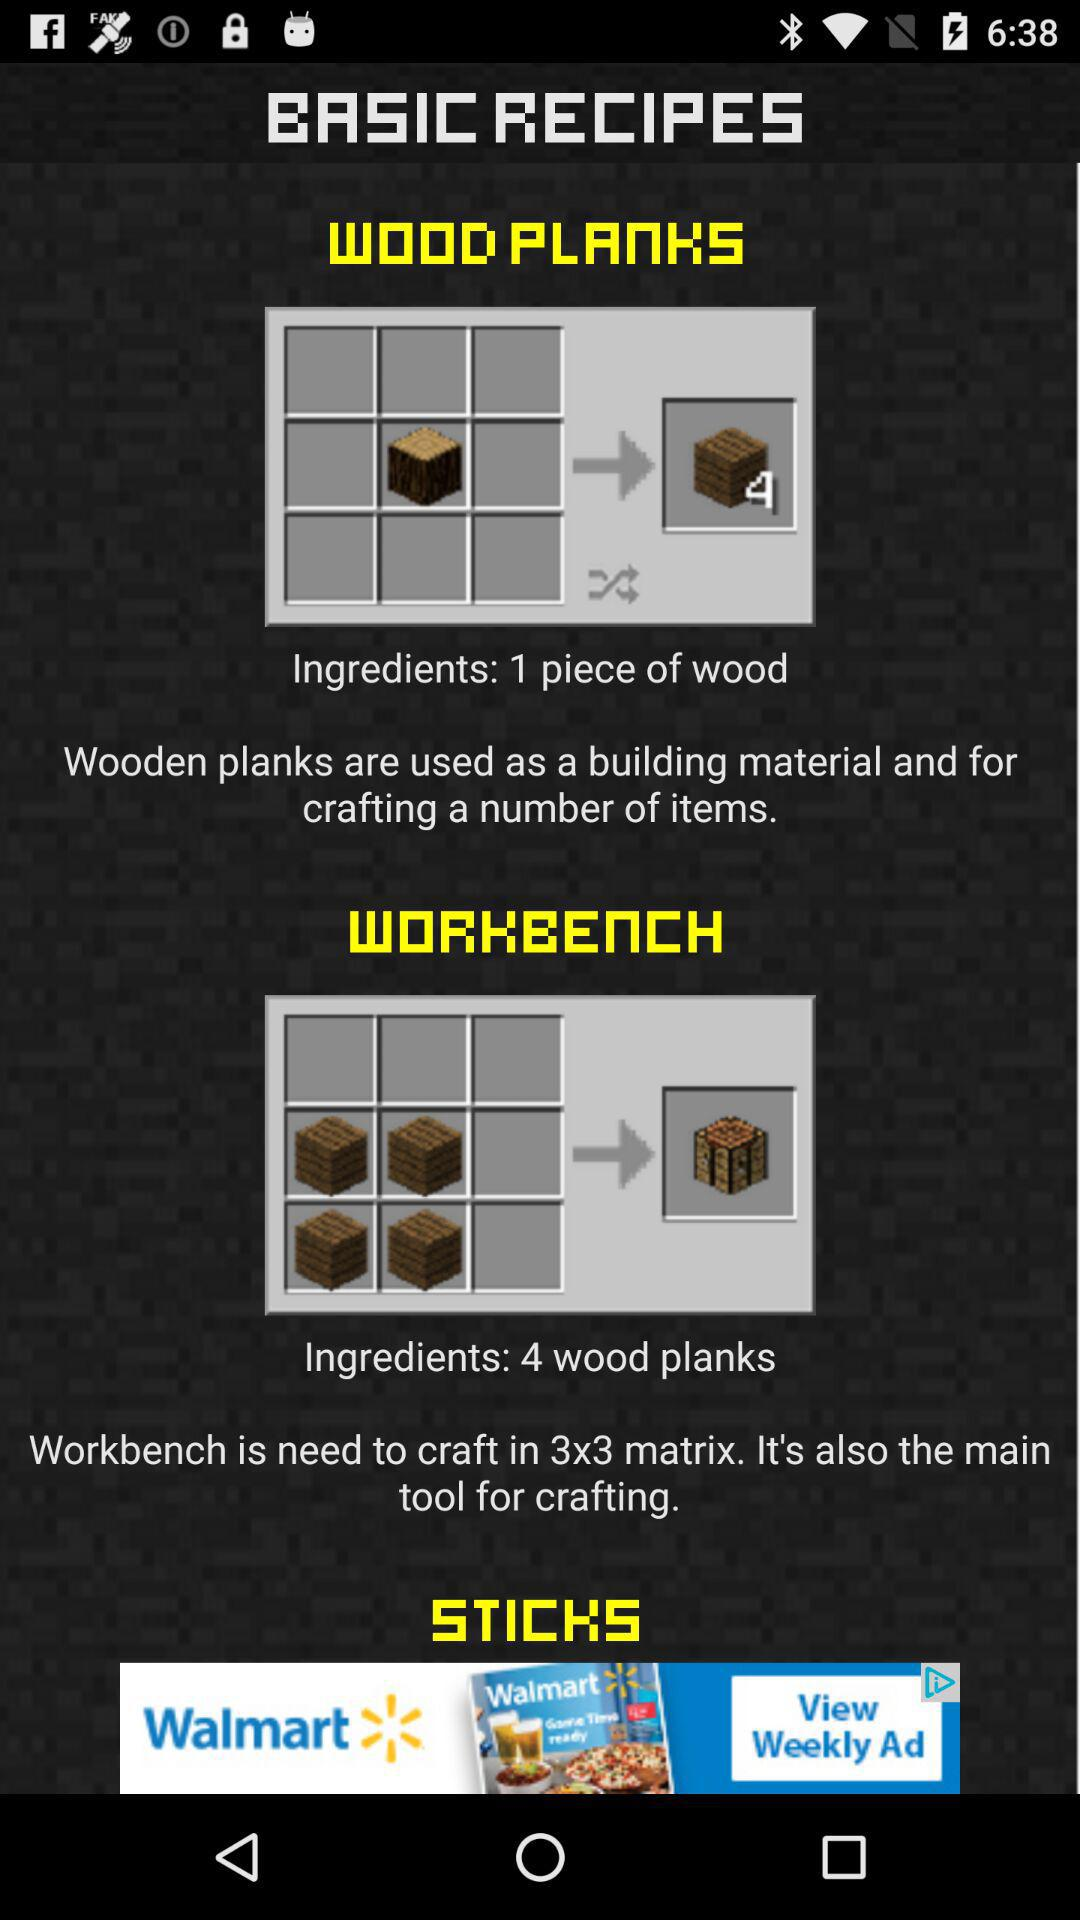What is the size of the matrix? The size of the matrix is 3×3. 